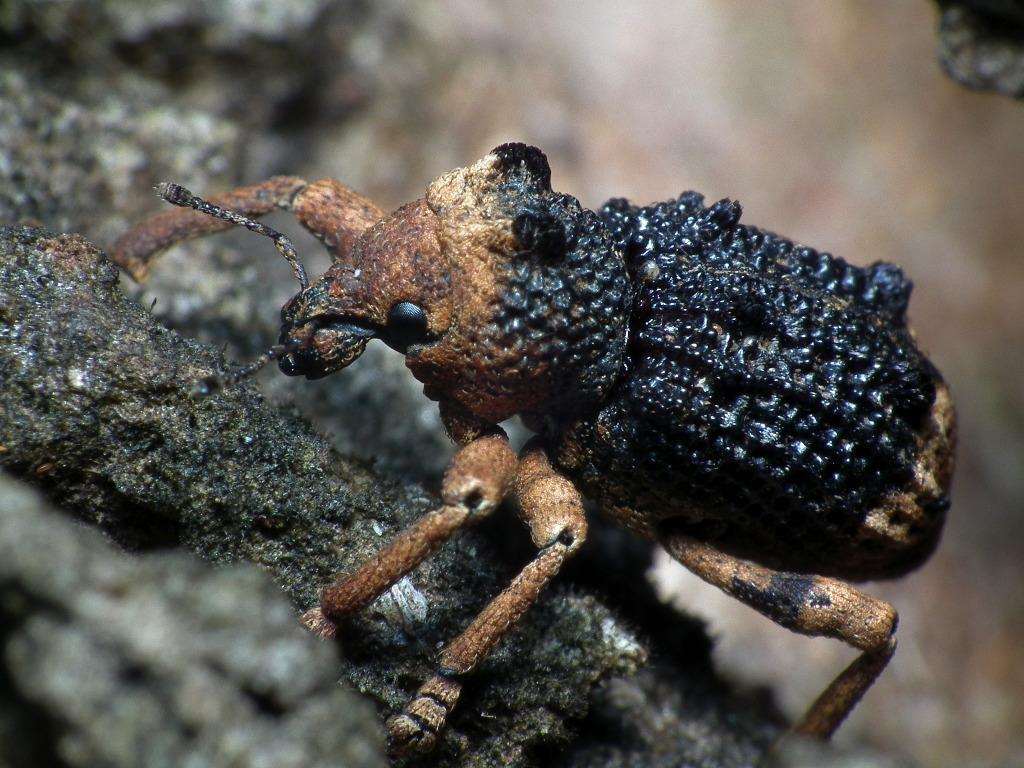What type of insect can be seen in the image? There is a black and brown insect in the image. Can you describe the quality of the background in the image? The image is blurry in the background. How many potatoes are visible in the image? There are no potatoes present in the image. What type of houses can be seen in the background of the image? The image does not show any houses, and the background is blurry. What type of vacation is depicted in the image? There is no indication of a vacation in the image; it features a black and brown insect and a blurry background. 